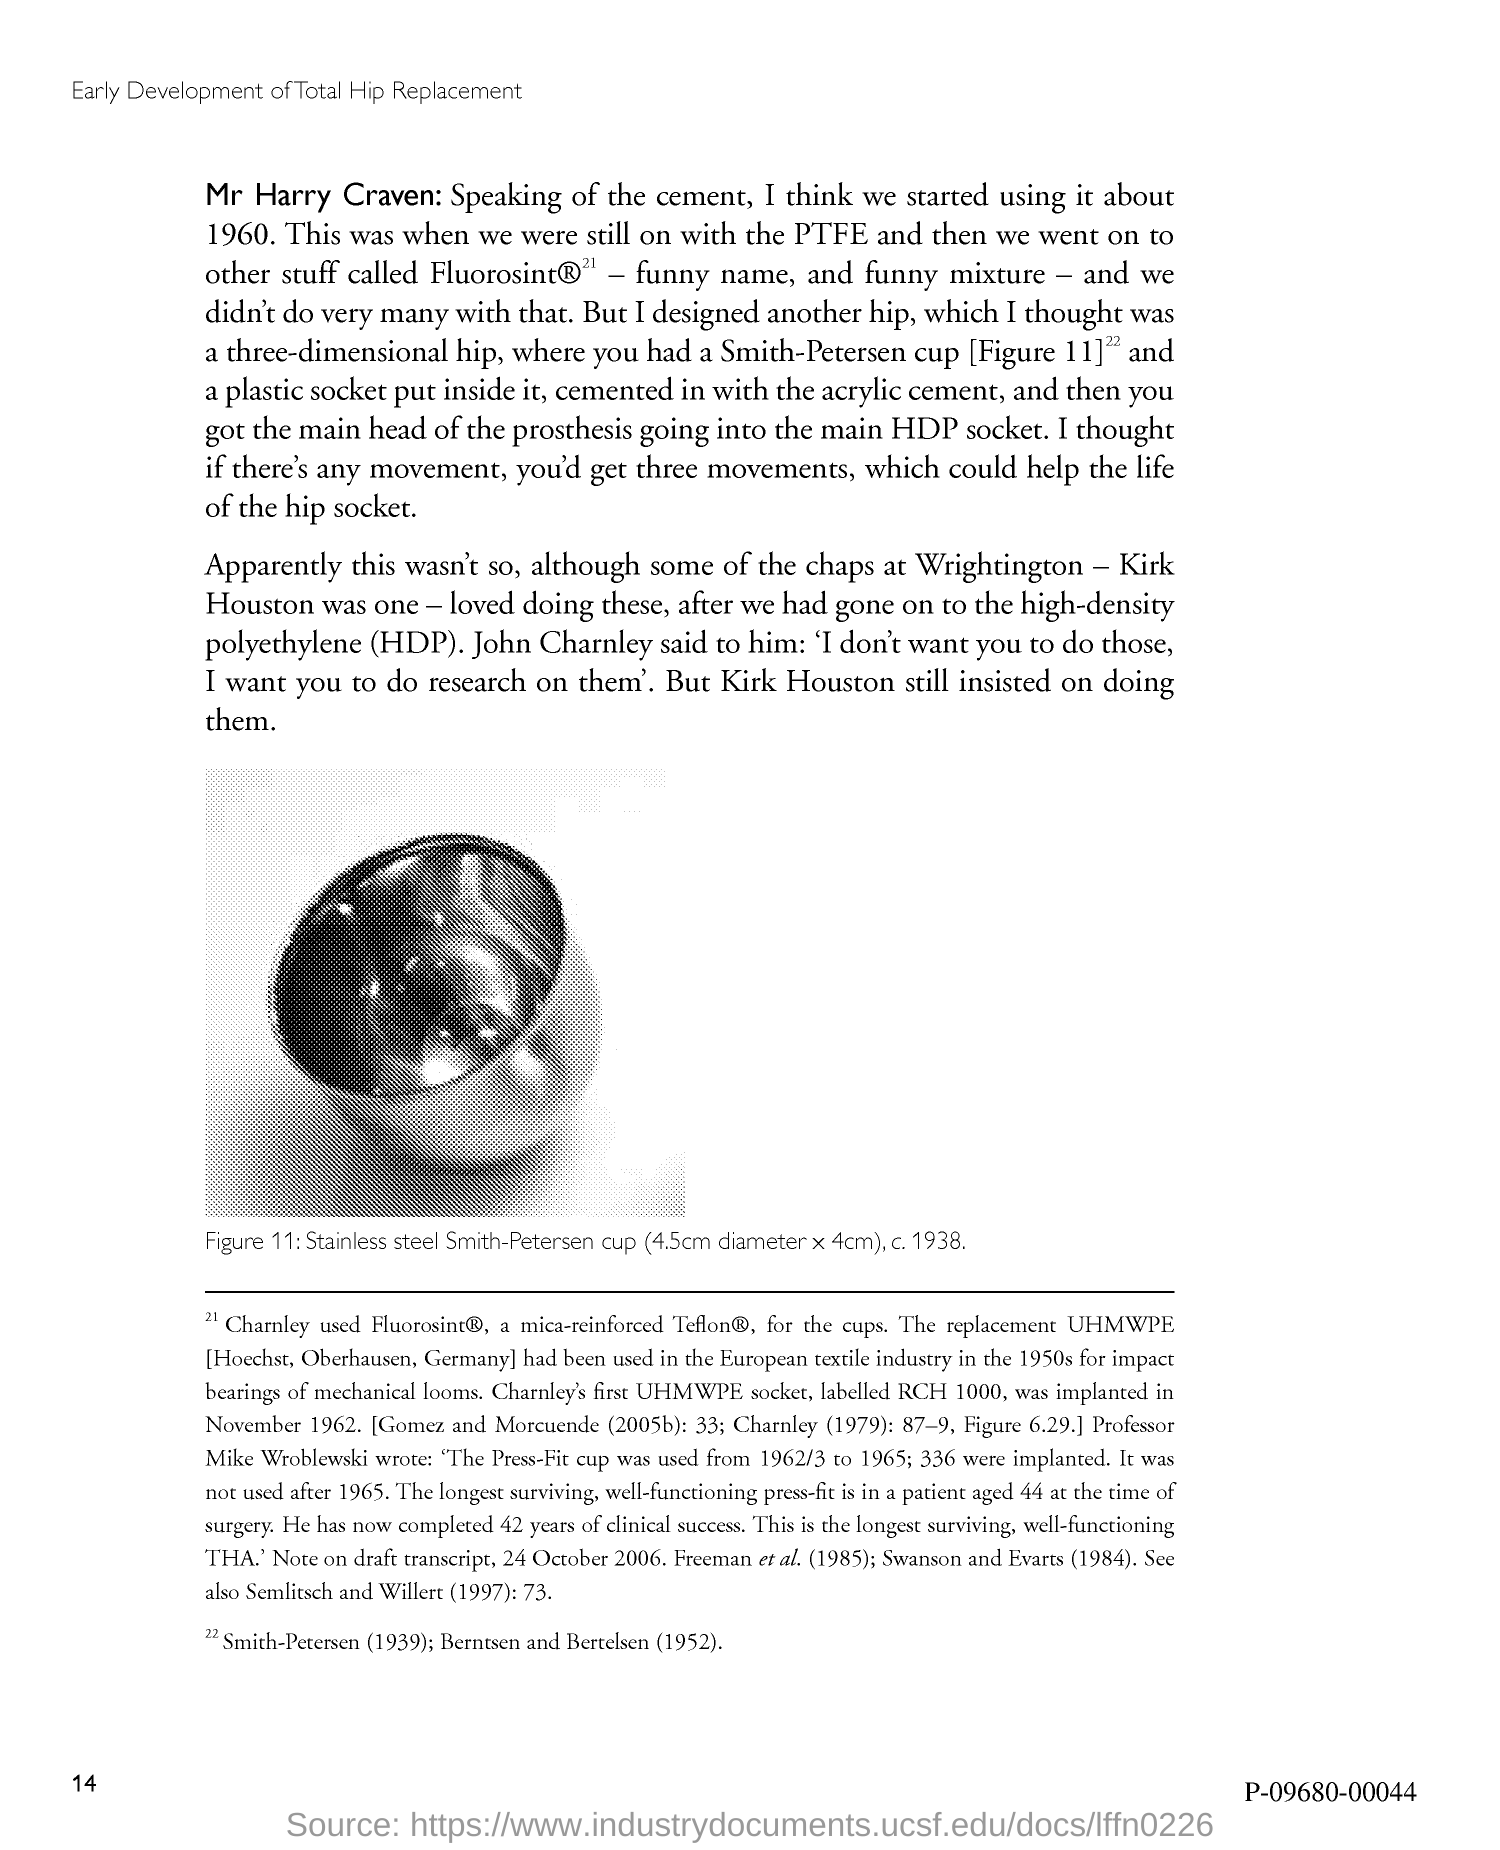What is the Page Number?
Offer a terse response. 14. 